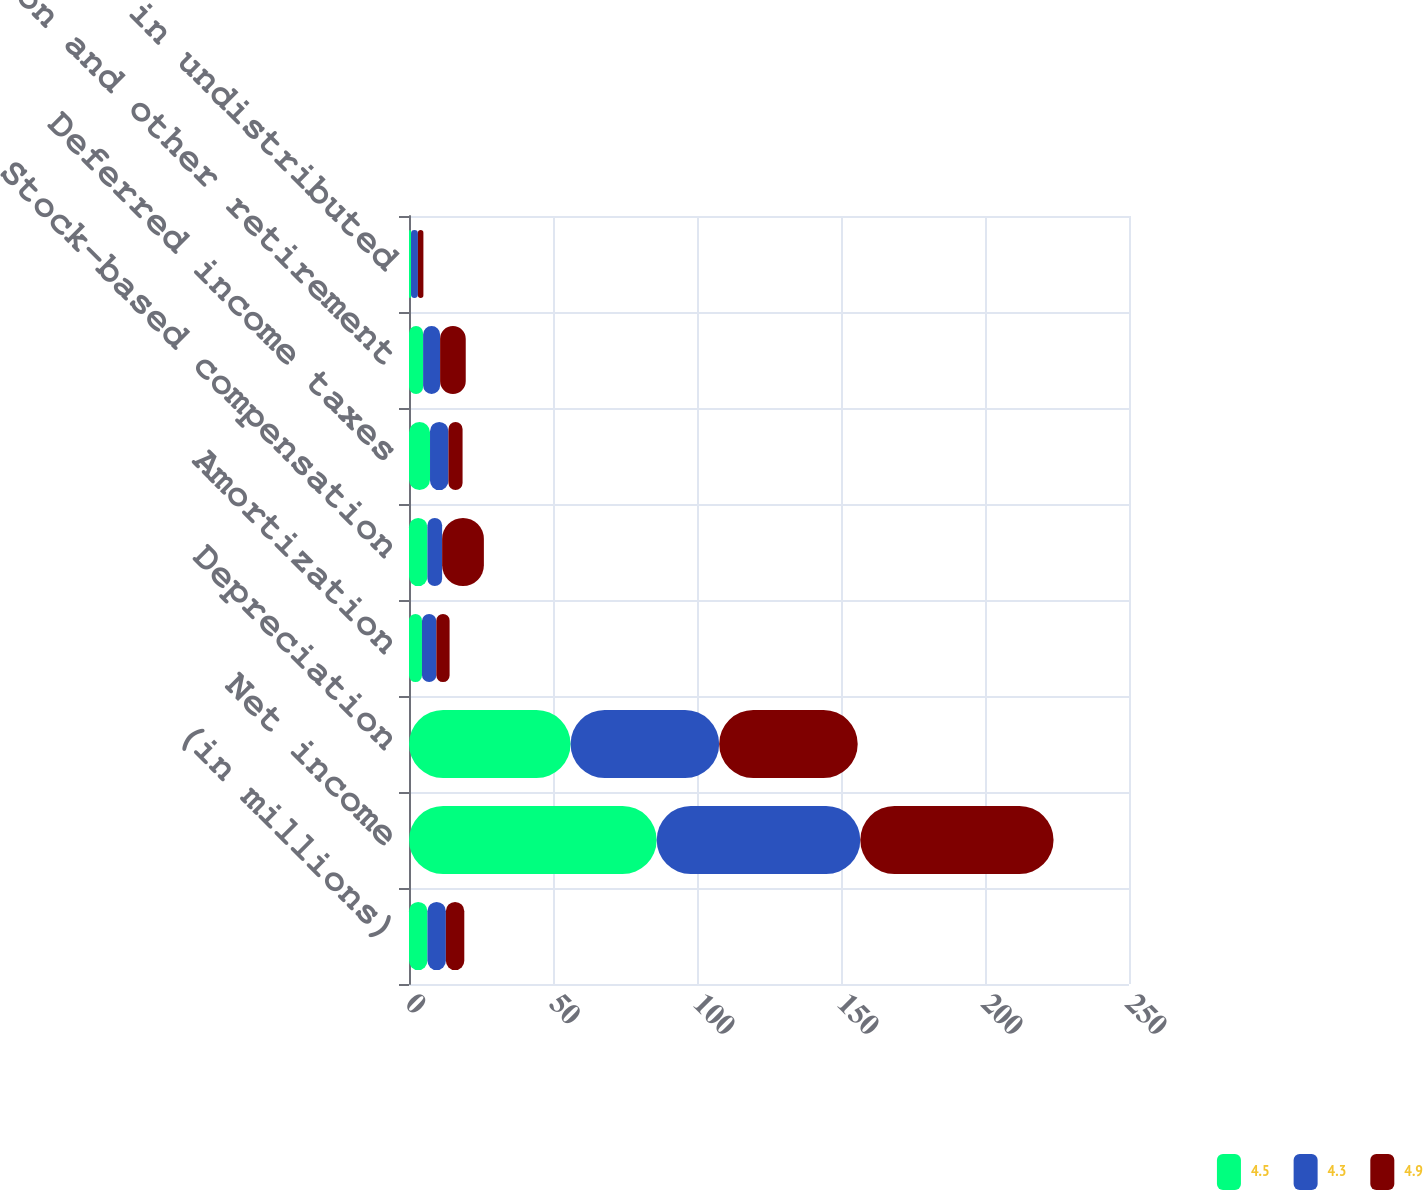<chart> <loc_0><loc_0><loc_500><loc_500><stacked_bar_chart><ecel><fcel>(in millions)<fcel>Net income<fcel>Depreciation<fcel>Amortization<fcel>Stock-based compensation<fcel>Deferred income taxes<fcel>Pension and other retirement<fcel>Equity in undistributed<nl><fcel>4.5<fcel>6.4<fcel>86<fcel>56.1<fcel>4.5<fcel>6.4<fcel>7.3<fcel>4.9<fcel>0.7<nl><fcel>4.3<fcel>6.4<fcel>70.7<fcel>51.6<fcel>5<fcel>5.1<fcel>6.4<fcel>5.9<fcel>2.4<nl><fcel>4.9<fcel>6.4<fcel>67.1<fcel>48.1<fcel>4.6<fcel>14.5<fcel>4.9<fcel>8.9<fcel>1.9<nl></chart> 